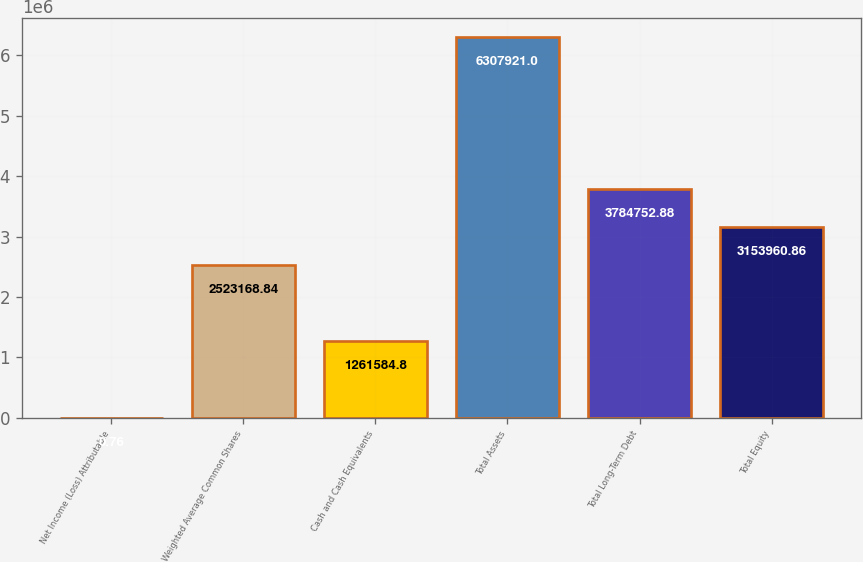Convert chart to OTSL. <chart><loc_0><loc_0><loc_500><loc_500><bar_chart><fcel>Net Income (Loss) Attributable<fcel>Weighted Average Common Shares<fcel>Cash and Cash Equivalents<fcel>Total Assets<fcel>Total Long-Term Debt<fcel>Total Equity<nl><fcel>0.76<fcel>2.52317e+06<fcel>1.26158e+06<fcel>6.30792e+06<fcel>3.78475e+06<fcel>3.15396e+06<nl></chart> 